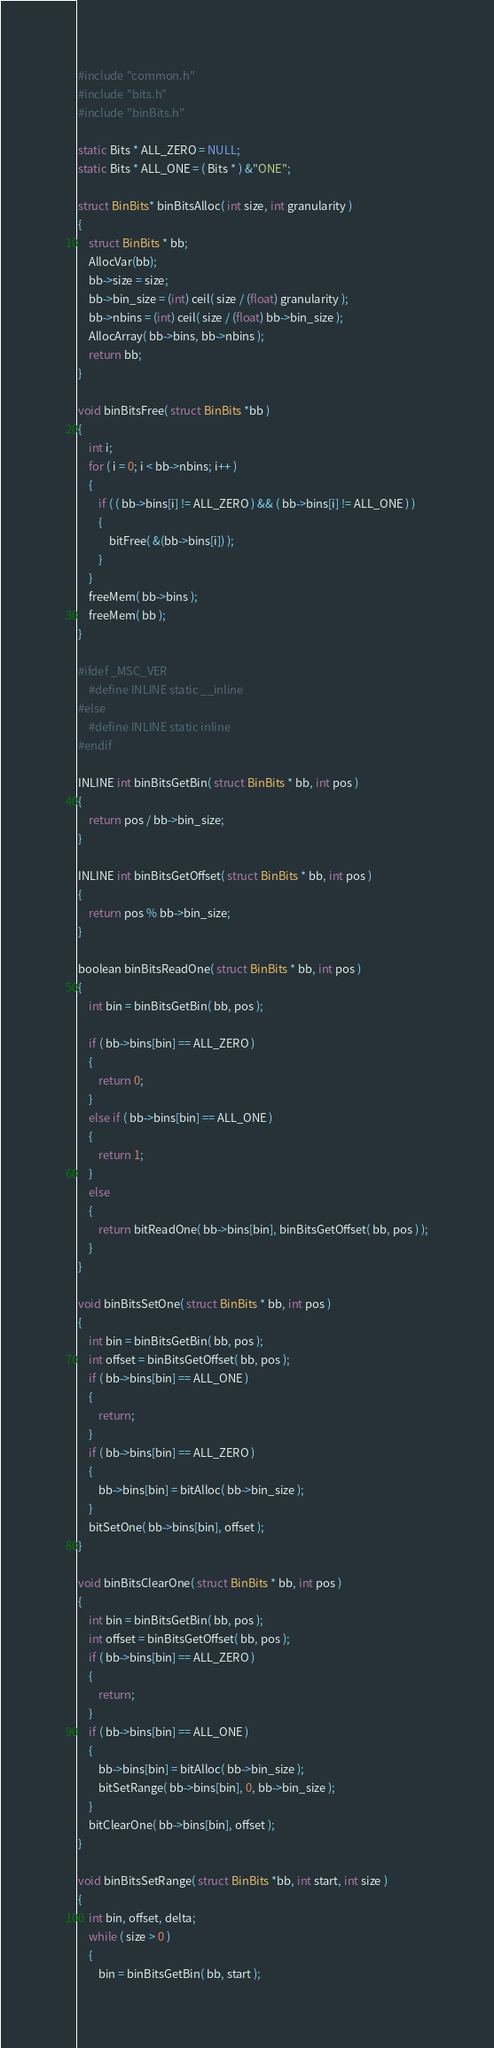<code> <loc_0><loc_0><loc_500><loc_500><_C_>#include "common.h"
#include "bits.h"
#include "binBits.h"

static Bits * ALL_ZERO = NULL;
static Bits * ALL_ONE = ( Bits * ) &"ONE";

struct BinBits* binBitsAlloc( int size, int granularity )
{
    struct BinBits * bb;
    AllocVar(bb);
    bb->size = size;
    bb->bin_size = (int) ceil( size / (float) granularity );
    bb->nbins = (int) ceil( size / (float) bb->bin_size );
    AllocArray( bb->bins, bb->nbins );
    return bb;
}

void binBitsFree( struct BinBits *bb )
{
    int i;
    for ( i = 0; i < bb->nbins; i++ )
    {
        if ( ( bb->bins[i] != ALL_ZERO ) && ( bb->bins[i] != ALL_ONE ) )
        {
            bitFree( &(bb->bins[i]) );
        }
    }
    freeMem( bb->bins );
    freeMem( bb );
}

#ifdef _MSC_VER
    #define INLINE static __inline
#else
    #define INLINE static inline
#endif

INLINE int binBitsGetBin( struct BinBits * bb, int pos )
{
    return pos / bb->bin_size;
}

INLINE int binBitsGetOffset( struct BinBits * bb, int pos )
{
    return pos % bb->bin_size;
}

boolean binBitsReadOne( struct BinBits * bb, int pos )
{
    int bin = binBitsGetBin( bb, pos );
    
    if ( bb->bins[bin] == ALL_ZERO )
    {
        return 0;
    }
    else if ( bb->bins[bin] == ALL_ONE )
    {
        return 1;
    }
    else
    {
        return bitReadOne( bb->bins[bin], binBitsGetOffset( bb, pos ) );
    }
}

void binBitsSetOne( struct BinBits * bb, int pos )
{
    int bin = binBitsGetBin( bb, pos );  
    int offset = binBitsGetOffset( bb, pos );
    if ( bb->bins[bin] == ALL_ONE )
    {
        return;
    }
    if ( bb->bins[bin] == ALL_ZERO )
    {
        bb->bins[bin] = bitAlloc( bb->bin_size );
    }
    bitSetOne( bb->bins[bin], offset );
}

void binBitsClearOne( struct BinBits * bb, int pos )
{
    int bin = binBitsGetBin( bb, pos );  
    int offset = binBitsGetOffset( bb, pos );
    if ( bb->bins[bin] == ALL_ZERO )
    {
        return;
    }
    if ( bb->bins[bin] == ALL_ONE )
    {
        bb->bins[bin] = bitAlloc( bb->bin_size );
        bitSetRange( bb->bins[bin], 0, bb->bin_size );
    }
    bitClearOne( bb->bins[bin], offset );
}

void binBitsSetRange( struct BinBits *bb, int start, int size )
{
    int bin, offset, delta;
    while ( size > 0 )
    {
        bin = binBitsGetBin( bb, start );  </code> 